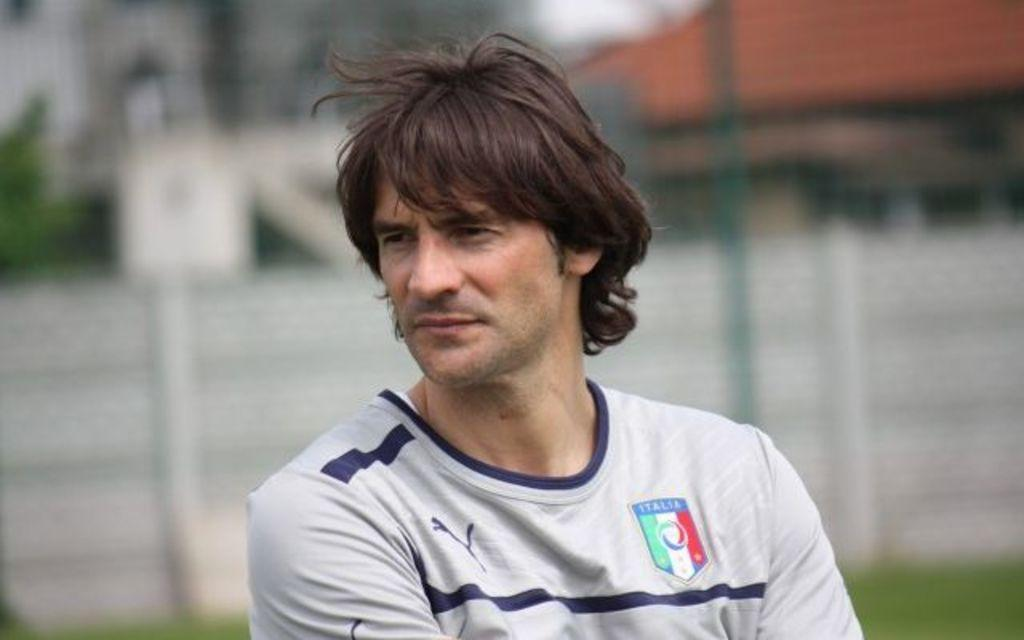<image>
Offer a succinct explanation of the picture presented. man standing wearing gray italia jersey with a fence behind him 